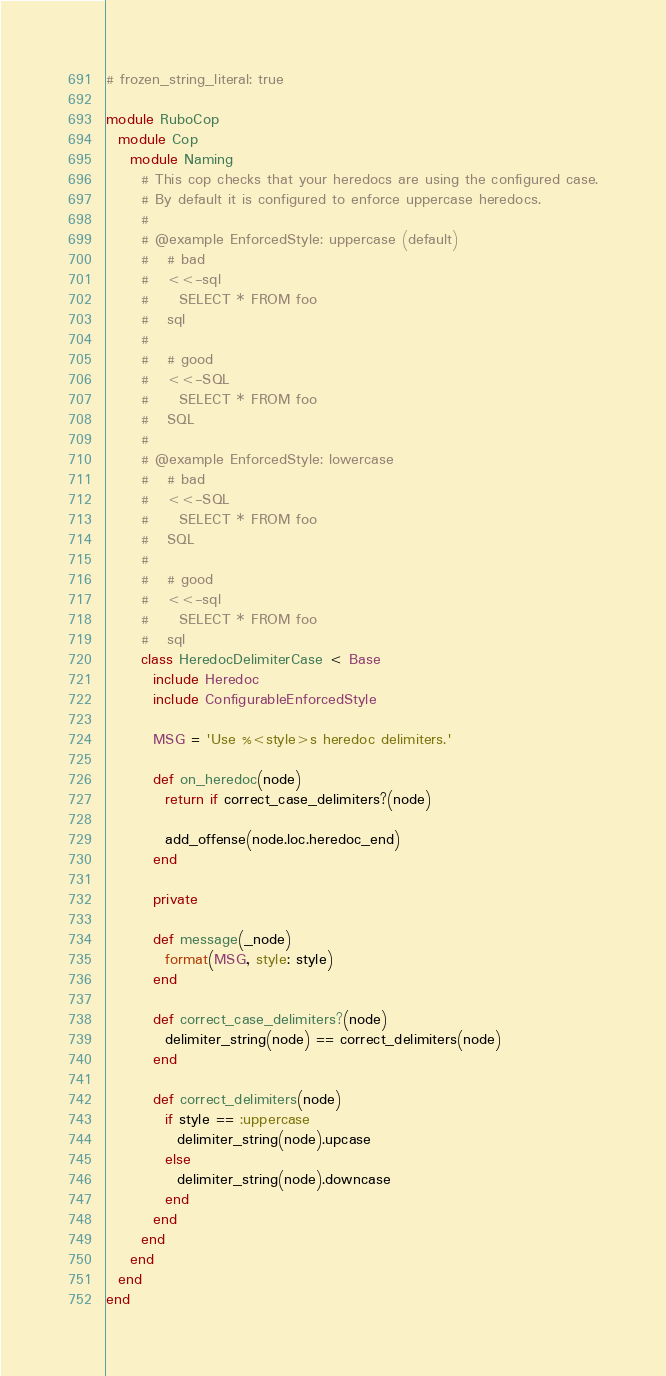<code> <loc_0><loc_0><loc_500><loc_500><_Ruby_># frozen_string_literal: true

module RuboCop
  module Cop
    module Naming
      # This cop checks that your heredocs are using the configured case.
      # By default it is configured to enforce uppercase heredocs.
      #
      # @example EnforcedStyle: uppercase (default)
      #   # bad
      #   <<-sql
      #     SELECT * FROM foo
      #   sql
      #
      #   # good
      #   <<-SQL
      #     SELECT * FROM foo
      #   SQL
      #
      # @example EnforcedStyle: lowercase
      #   # bad
      #   <<-SQL
      #     SELECT * FROM foo
      #   SQL
      #
      #   # good
      #   <<-sql
      #     SELECT * FROM foo
      #   sql
      class HeredocDelimiterCase < Base
        include Heredoc
        include ConfigurableEnforcedStyle

        MSG = 'Use %<style>s heredoc delimiters.'

        def on_heredoc(node)
          return if correct_case_delimiters?(node)

          add_offense(node.loc.heredoc_end)
        end

        private

        def message(_node)
          format(MSG, style: style)
        end

        def correct_case_delimiters?(node)
          delimiter_string(node) == correct_delimiters(node)
        end

        def correct_delimiters(node)
          if style == :uppercase
            delimiter_string(node).upcase
          else
            delimiter_string(node).downcase
          end
        end
      end
    end
  end
end
</code> 